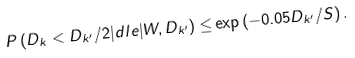Convert formula to latex. <formula><loc_0><loc_0><loc_500><loc_500>P \left ( D _ { k } < D _ { k ^ { \prime } } / 2 | d l e | W , D _ { k ^ { \prime } } \right ) \leq & \exp \left ( - 0 . 0 5 D _ { k ^ { \prime } } / S \right ) .</formula> 